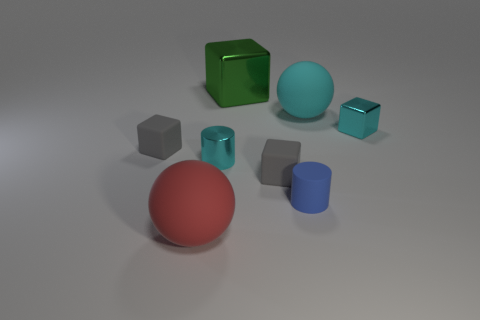Add 1 gray rubber blocks. How many objects exist? 9 Subtract all spheres. How many objects are left? 6 Subtract all cyan blocks. Subtract all red matte things. How many objects are left? 6 Add 6 green blocks. How many green blocks are left? 7 Add 3 large purple objects. How many large purple objects exist? 3 Subtract 0 gray spheres. How many objects are left? 8 